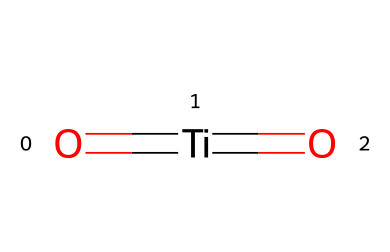What is the main element in titanium dioxide? The SMILES representation shows the presence of titanium (Ti) as the central atom of the structure, indicating that titanium is the main element in this compound.
Answer: titanium How many oxygen atoms are in titanium dioxide? The structure contains two oxygen atoms (O) bonded to the titanium atom (Ti), which confirms that there are two oxygens in titanium dioxide.
Answer: 2 What is the chemical formula for titanium dioxide? The compound is known as titanium dioxide, which is represented by the formula TiO2, derived from its composition of one titanium atom and two oxygen atoms.
Answer: TiO2 What type of bonds are present in titanium dioxide? The chemical structure shows double bonds between titanium (Ti) and each of the two oxygen atoms (O), indicating that there are double bonds in the compound.
Answer: double bonds How does titanium dioxide contribute to UV protection in sunscreens? Titanium dioxide functions as a physical sunscreen agent that scatters and reflects UV radiation due to its solid structure, thereby providing protection against UV rays.
Answer: scatters and reflects Why is titanium dioxide used in the cosmetic industry? Titanium dioxide is widely used in cosmetics due to its excellent ability to provide coverage and UV protection, along with being non-reactive and safe for skin application.
Answer: coverage and UV protection What is the natural state of titanium dioxide? Titanium dioxide typically occurs naturally in the mineral forms of rutile and anatase, which are used in various applications, including cosmetics and sunscreens.
Answer: rutile and anatase 